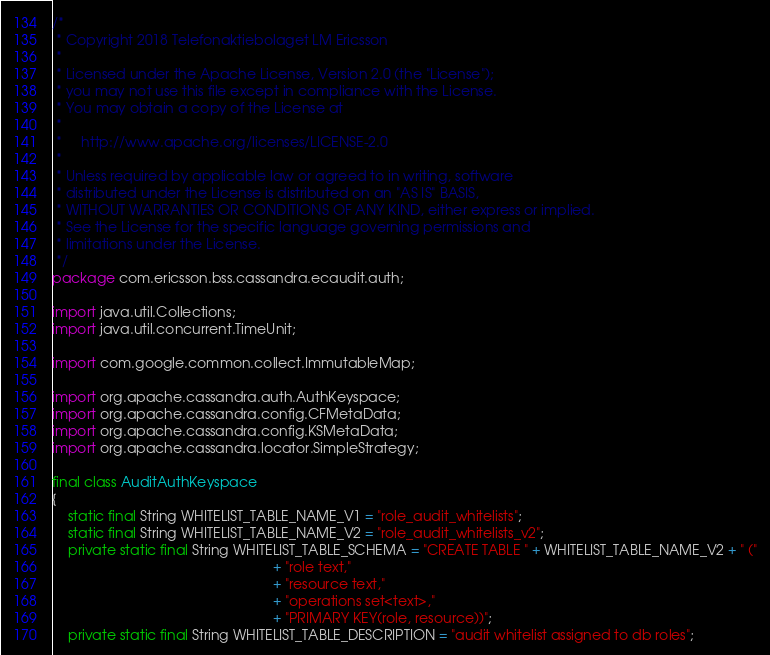Convert code to text. <code><loc_0><loc_0><loc_500><loc_500><_Java_>/*
 * Copyright 2018 Telefonaktiebolaget LM Ericsson
 *
 * Licensed under the Apache License, Version 2.0 (the "License");
 * you may not use this file except in compliance with the License.
 * You may obtain a copy of the License at
 *
 *     http://www.apache.org/licenses/LICENSE-2.0
 *
 * Unless required by applicable law or agreed to in writing, software
 * distributed under the License is distributed on an "AS IS" BASIS,
 * WITHOUT WARRANTIES OR CONDITIONS OF ANY KIND, either express or implied.
 * See the License for the specific language governing permissions and
 * limitations under the License.
 */
package com.ericsson.bss.cassandra.ecaudit.auth;

import java.util.Collections;
import java.util.concurrent.TimeUnit;

import com.google.common.collect.ImmutableMap;

import org.apache.cassandra.auth.AuthKeyspace;
import org.apache.cassandra.config.CFMetaData;
import org.apache.cassandra.config.KSMetaData;
import org.apache.cassandra.locator.SimpleStrategy;

final class AuditAuthKeyspace
{
    static final String WHITELIST_TABLE_NAME_V1 = "role_audit_whitelists";
    static final String WHITELIST_TABLE_NAME_V2 = "role_audit_whitelists_v2";
    private static final String WHITELIST_TABLE_SCHEMA = "CREATE TABLE " + WHITELIST_TABLE_NAME_V2 + " ("
                                                         + "role text,"
                                                         + "resource text,"
                                                         + "operations set<text>,"
                                                         + "PRIMARY KEY(role, resource))";
    private static final String WHITELIST_TABLE_DESCRIPTION = "audit whitelist assigned to db roles";</code> 